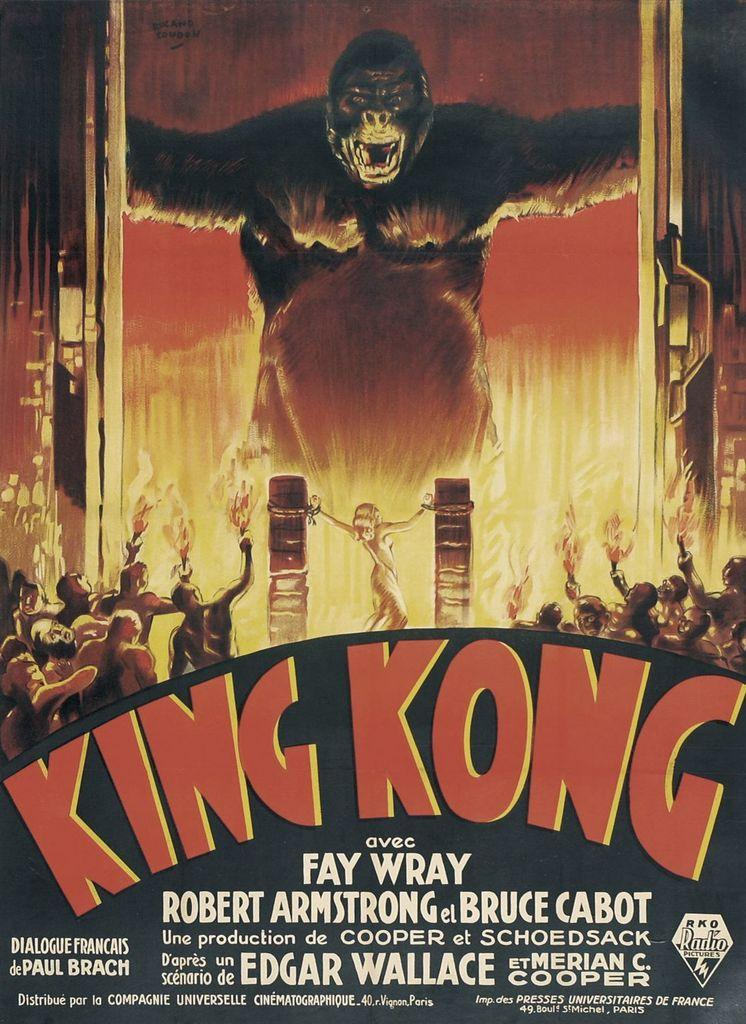<image>
Relay a brief, clear account of the picture shown. King Kong movie poster with Fay Wray, Robert Armstrong, and Bruce Cabot. 